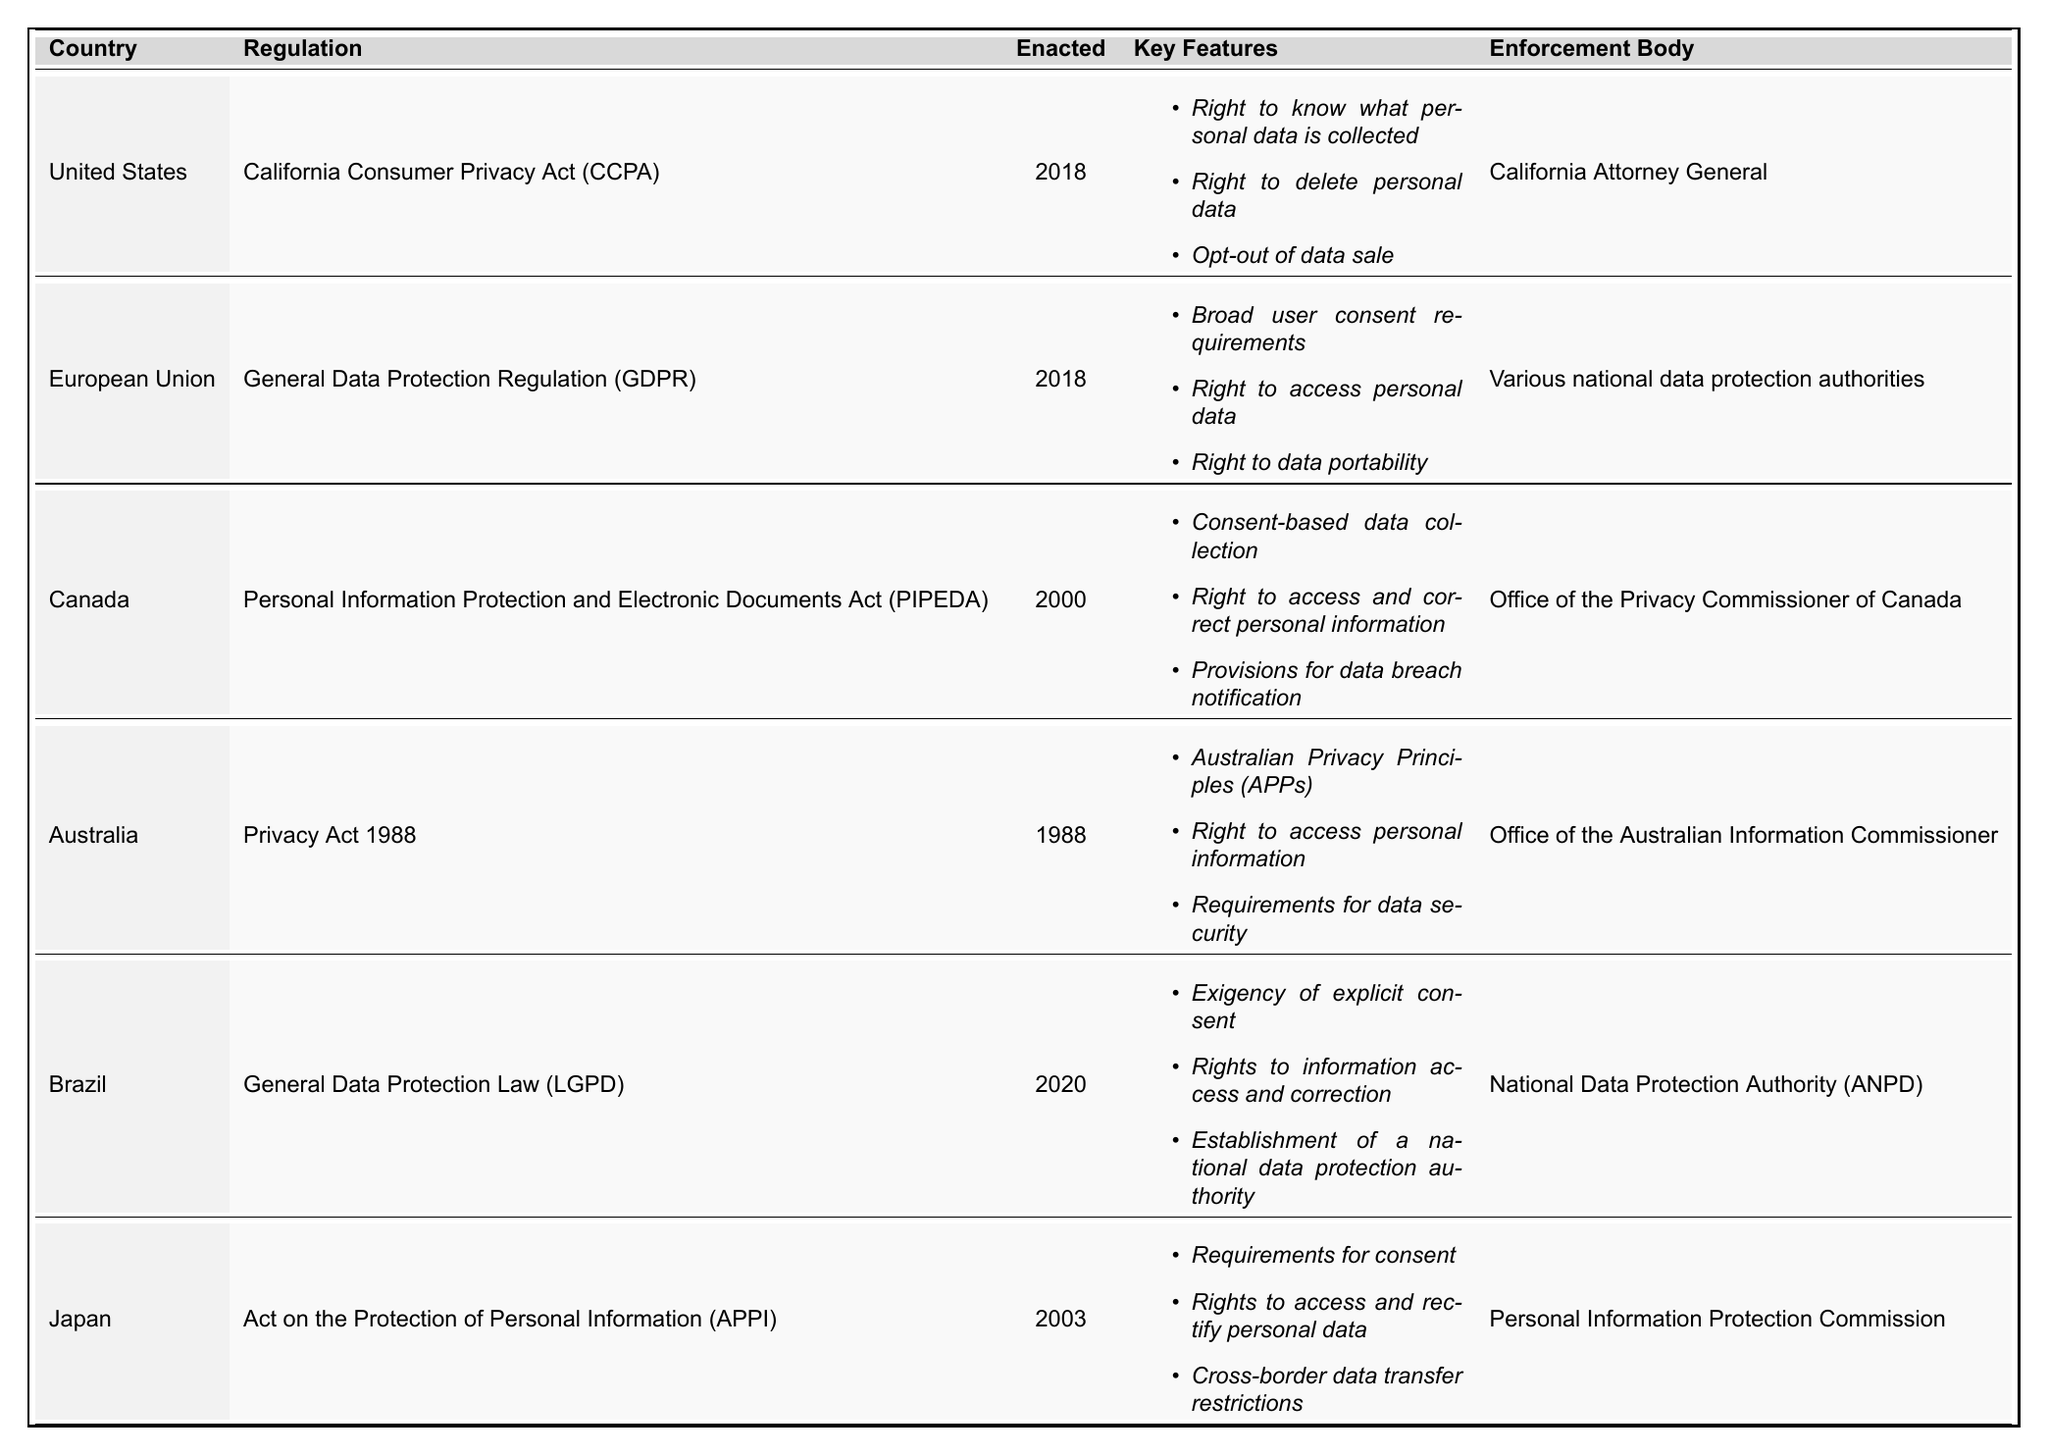What regulation was enacted in Canada? The table lists the regulations by country, and for Canada, it specifies the regulation as the "Personal Information Protection and Electronic Documents Act (PIPEDA)."
Answer: Personal Information Protection and Electronic Documents Act (PIPEDA) Which country has the earliest data privacy regulation? By checking the "Enacted" year column in the table, Australia has the earliest regulation, the Privacy Act, which was enacted in 1988.
Answer: Australia Is there a requirement for explicit consent in Brazil's data privacy regulation? The key features for Brazil's General Data Protection Law (LGPD) state "Exigency of explicit consent," confirming that this requirement exists.
Answer: Yes Which country has multiple enforcement bodies for its data regulation? The European Union's GDPR mentions "Various national data protection authorities" as the enforcement body, indicating more than one enforcement entity.
Answer: European Union What do the key features of the GDPR include? The table outlines that the key features of GDPR include "Broad user consent requirements," "Right to access personal data," and "Right to data portability."
Answer: Broad user consent requirements, Right to access personal data, Right to data portability How does the number of key features compare between the U.S. and Canada? The U.S. has three key features listed for the CCPA, while Canada also has three key features for PIPEDA, making them equal in number.
Answer: Equal Which country’s privacy regulation includes provisions for data breach notification? The table indicates that the Canadian regulation, PIPEDA, includes "Provisions for data breach notification."
Answer: Canada What rights are provided to individuals under the Japanese data protection law? The key features for Japan's APPI mention "Rights to access and rectify personal data" and "Requirements for consent," detailing the rights individuals have.
Answer: Rights to access and rectify personal data, Requirements for consent List the countries that enacted their data protection regulations in the year 2018. The countries with regulations enacted in 2018, as per the table, are the United States (CCPA) and the European Union (GDPR).
Answer: United States, European Union What is the purpose of the enforcement body listed for Brazil's LGPD? The enforcement body is the "National Data Protection Authority (ANPD)," which is established to enforce the LGPD and protect personal data in Brazil.
Answer: To enforce the LGPD and protect personal data in Brazil 